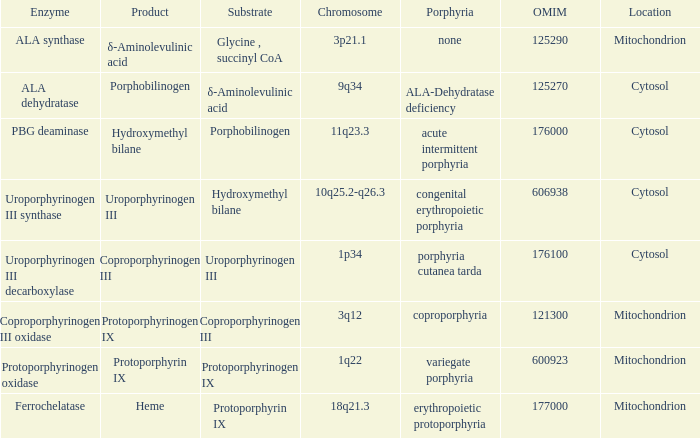Which substrate has an OMIM of 176000? Porphobilinogen. 